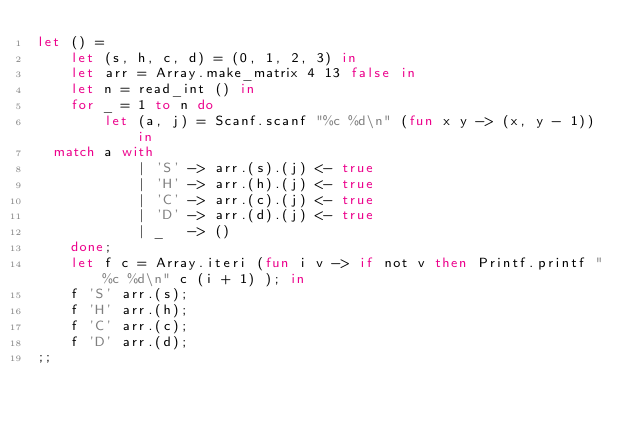Convert code to text. <code><loc_0><loc_0><loc_500><loc_500><_OCaml_>let () = 
    let (s, h, c, d) = (0, 1, 2, 3) in
    let arr = Array.make_matrix 4 13 false in
    let n = read_int () in
    for _ = 1 to n do 
        let (a, j) = Scanf.scanf "%c %d\n" (fun x y -> (x, y - 1)) in
	match a with
            | 'S' -> arr.(s).(j) <- true
            | 'H' -> arr.(h).(j) <- true
            | 'C' -> arr.(c).(j) <- true
            | 'D' -> arr.(d).(j) <- true
            | _   -> ()
    done;
    let f c = Array.iteri (fun i v -> if not v then Printf.printf "%c %d\n" c (i + 1) ); in
    f 'S' arr.(s);
    f 'H' arr.(h);
    f 'C' arr.(c);
    f 'D' arr.(d);
;;
</code> 